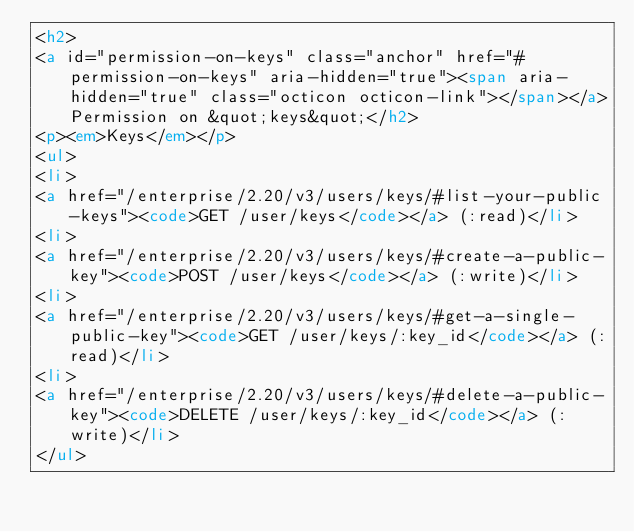Convert code to text. <code><loc_0><loc_0><loc_500><loc_500><_HTML_><h2>
<a id="permission-on-keys" class="anchor" href="#permission-on-keys" aria-hidden="true"><span aria-hidden="true" class="octicon octicon-link"></span></a>Permission on &quot;keys&quot;</h2>
<p><em>Keys</em></p>
<ul>
<li>
<a href="/enterprise/2.20/v3/users/keys/#list-your-public-keys"><code>GET /user/keys</code></a> (:read)</li>
<li>
<a href="/enterprise/2.20/v3/users/keys/#create-a-public-key"><code>POST /user/keys</code></a> (:write)</li>
<li>
<a href="/enterprise/2.20/v3/users/keys/#get-a-single-public-key"><code>GET /user/keys/:key_id</code></a> (:read)</li>
<li>
<a href="/enterprise/2.20/v3/users/keys/#delete-a-public-key"><code>DELETE /user/keys/:key_id</code></a> (:write)</li>
</ul></code> 